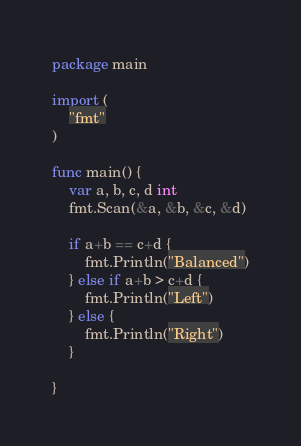Convert code to text. <code><loc_0><loc_0><loc_500><loc_500><_Go_>package main

import (
	"fmt"
)

func main() {
	var a, b, c, d int
	fmt.Scan(&a, &b, &c, &d)

	if a+b == c+d {
		fmt.Println("Balanced")
	} else if a+b > c+d {
		fmt.Println("Left")
	} else {
		fmt.Println("Right")
	}

}
</code> 